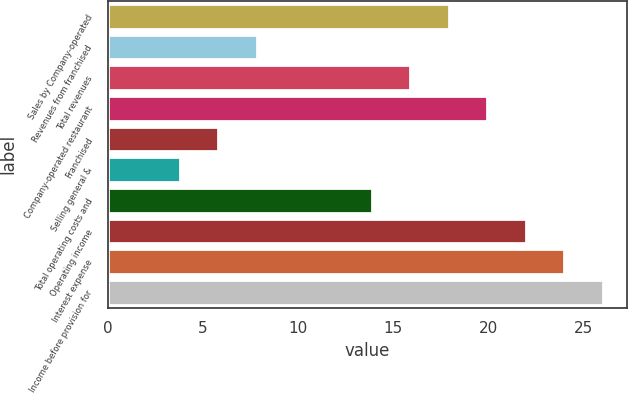Convert chart. <chart><loc_0><loc_0><loc_500><loc_500><bar_chart><fcel>Sales by Company-operated<fcel>Revenues from franchised<fcel>Total revenues<fcel>Company-operated restaurant<fcel>Franchised<fcel>Selling general &<fcel>Total operating costs and<fcel>Operating income<fcel>Interest expense<fcel>Income before provision for<nl><fcel>17.92<fcel>7.82<fcel>15.9<fcel>19.94<fcel>5.8<fcel>3.78<fcel>13.88<fcel>21.96<fcel>23.98<fcel>26<nl></chart> 